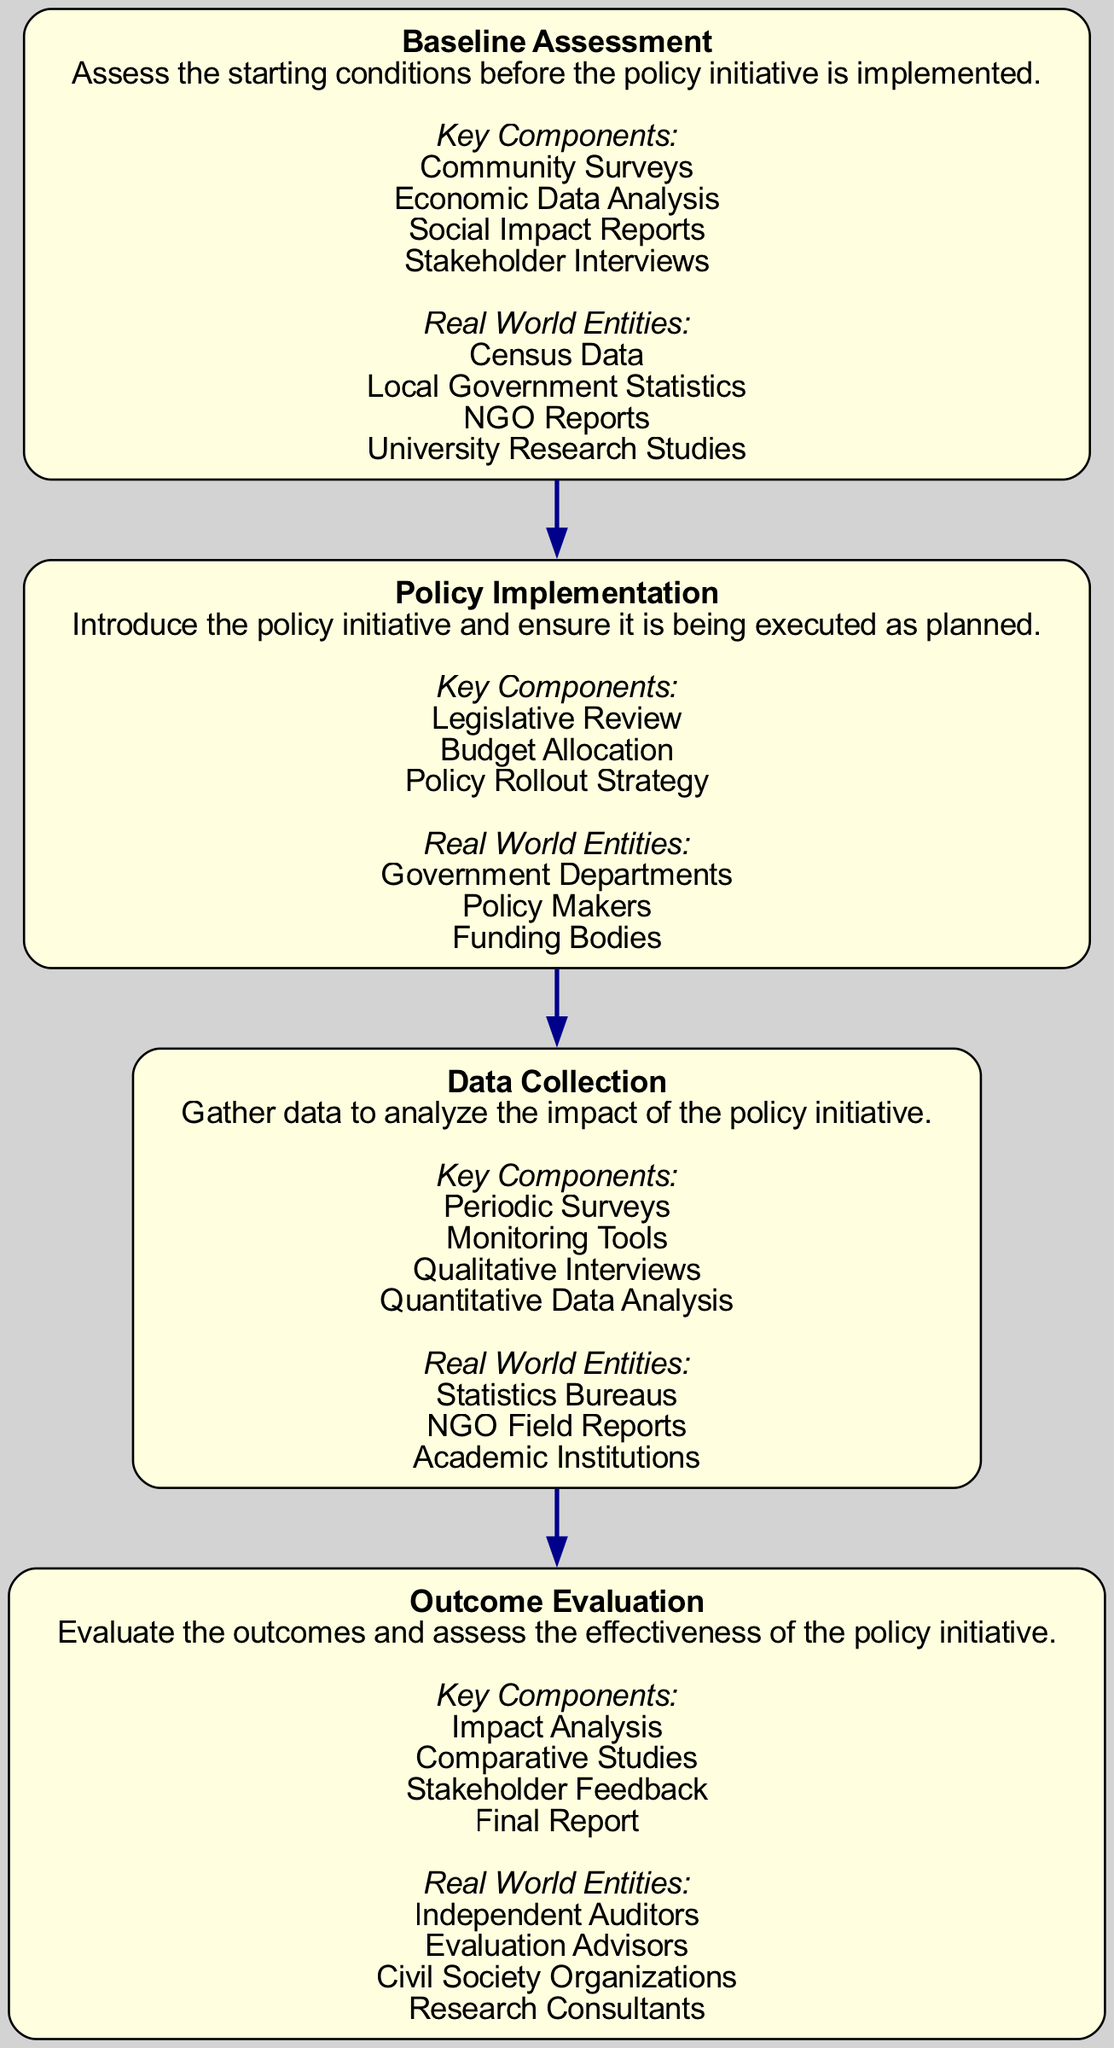What are the names of the four main stages in the impact assessment process? The diagram shows four elements: Baseline Assessment, Policy Implementation, Data Collection, and Outcome Evaluation.
Answer: Baseline Assessment, Policy Implementation, Data Collection, Outcome Evaluation What is the primary focus of the "Baseline Assessment" stage? The description in the diagram states that the Baseline Assessment stage is focused on assessing the starting conditions before the policy initiative is implemented.
Answer: Assess the starting conditions Which stage comes directly after "Policy Implementation"? The diagram indicates a sequential flow from Policy Implementation to Data Collection, meaning Data Collection is the stage that follows.
Answer: Data Collection How many key components are listed under "Outcome Evaluation"? The diagram outlines four key components under Outcome Evaluation, which are Impact Analysis, Comparative Studies, Stakeholder Feedback, and Final Report.
Answer: Four What type of entities are referenced as "Real World Entities" under "Data Collection"? The diagram lists Statistics Bureaus, NGO Field Reports, and Academic Institutions as the Real World Entities for the Data Collection stage.
Answer: Statistics Bureaus, NGO Field Reports, Academic Institutions In which stage would you find "Stakeholder Interviews" as a key component? According to the diagram, Stakeholder Interviews are part of the Key Components listed under Baseline Assessment.
Answer: Baseline Assessment What common purpose do "Community Surveys," "Economic Data Analysis," and "Social Impact Reports" serve? All these components aim to evaluate conditions before implementing the policy initiative, as specified under the Baseline Assessment.
Answer: Evaluate conditions Which stage includes "Legislative Review" as a key component? The diagram specifies that Legislative Review is part of the key components involved in the Policy Implementation stage.
Answer: Policy Implementation Which two entities are identified under "Outcome Evaluation"? The diagram lists Independent Auditors and Evaluation Advisors under Real World Entities for Outcome Evaluation.
Answer: Independent Auditors, Evaluation Advisors 